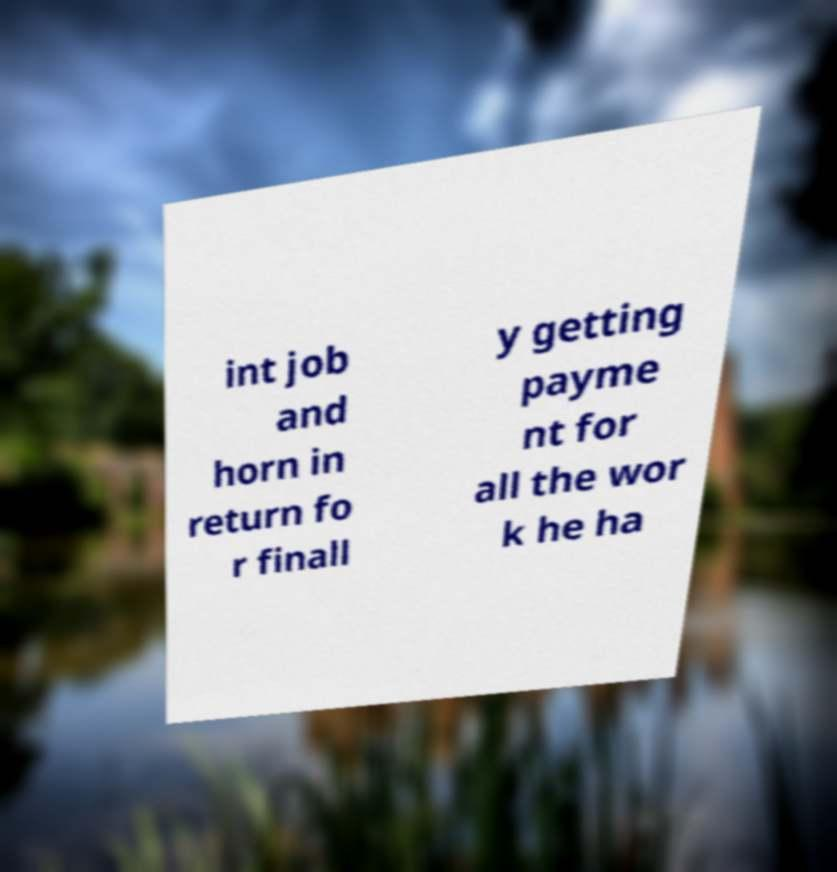What messages or text are displayed in this image? I need them in a readable, typed format. int job and horn in return fo r finall y getting payme nt for all the wor k he ha 